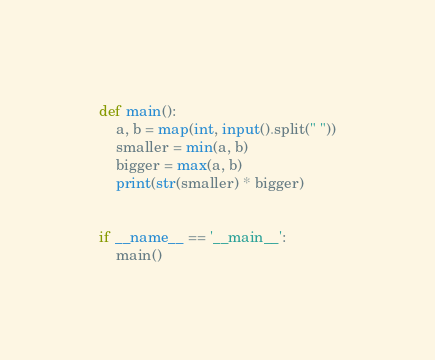<code> <loc_0><loc_0><loc_500><loc_500><_Python_>def main():
    a, b = map(int, input().split(" "))
    smaller = min(a, b)
    bigger = max(a, b)
    print(str(smaller) * bigger)


if __name__ == '__main__':
    main()
</code> 